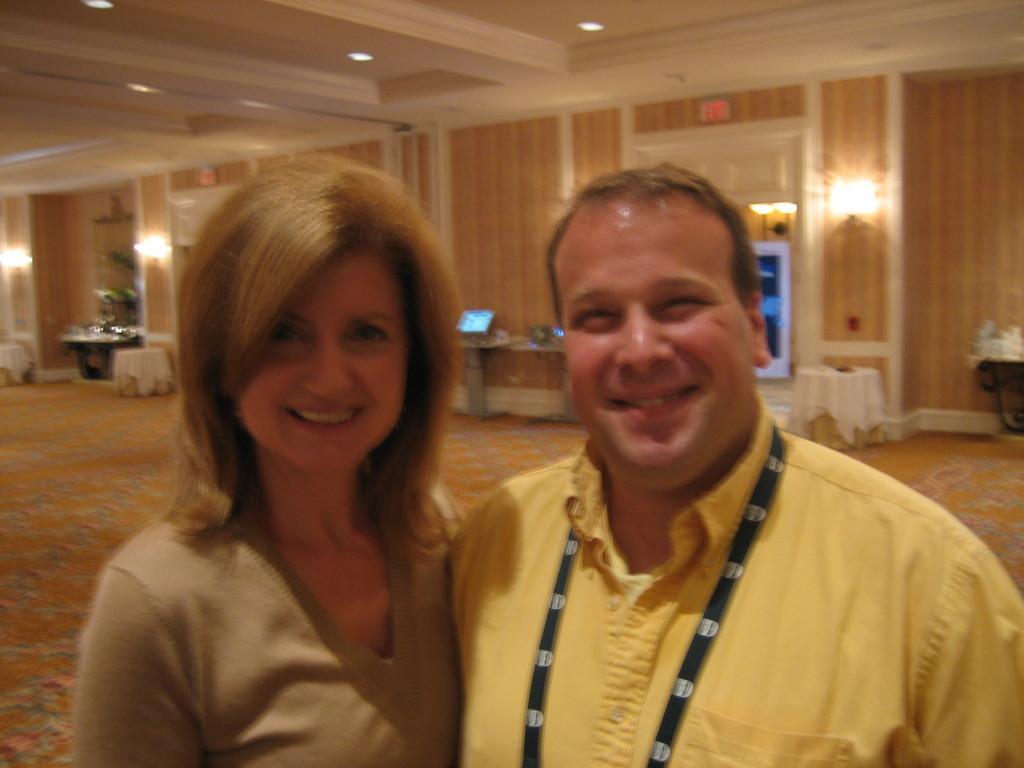Can you describe this image briefly? In the foreground of the image we can see a woman wearing brown color sweater, man wearing yellow color shirt standing together and in the background of the image there are some tables, flower vases, lights, doors and there is a wall. 